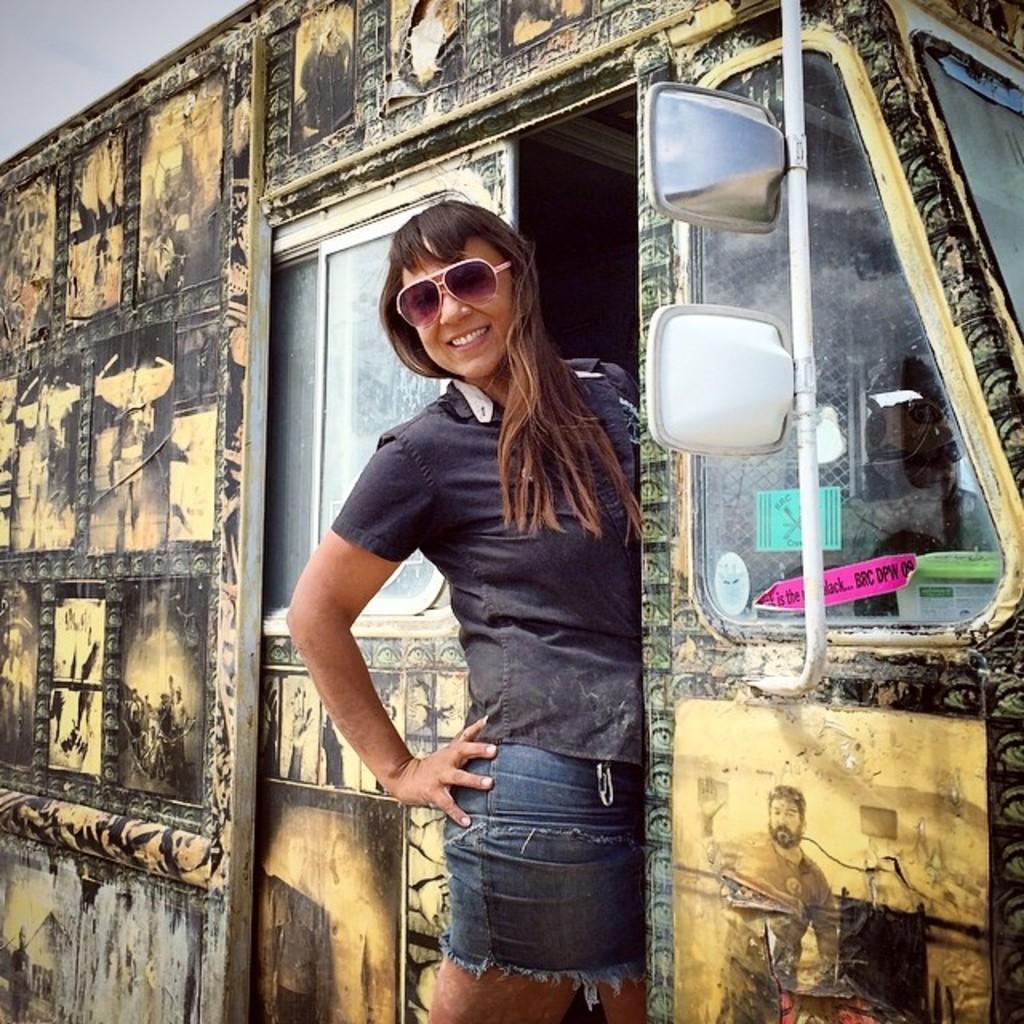In one or two sentences, can you explain what this image depicts? In the center of the image we can see one vehicle. And we can see one person is standing near the door of a vehicle and we can see she is smiling and she is wearing glasses. And we can see a few posts and some objects on the vehicle. In the background, we can see the sky. 